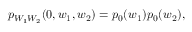Convert formula to latex. <formula><loc_0><loc_0><loc_500><loc_500>\begin{array} { r } { p _ { W _ { 1 } W _ { 2 } } ( 0 , w _ { 1 } , w _ { 2 } ) = p _ { 0 } ( w _ { 1 } ) p _ { 0 } ( w _ { 2 } ) , } \end{array}</formula> 